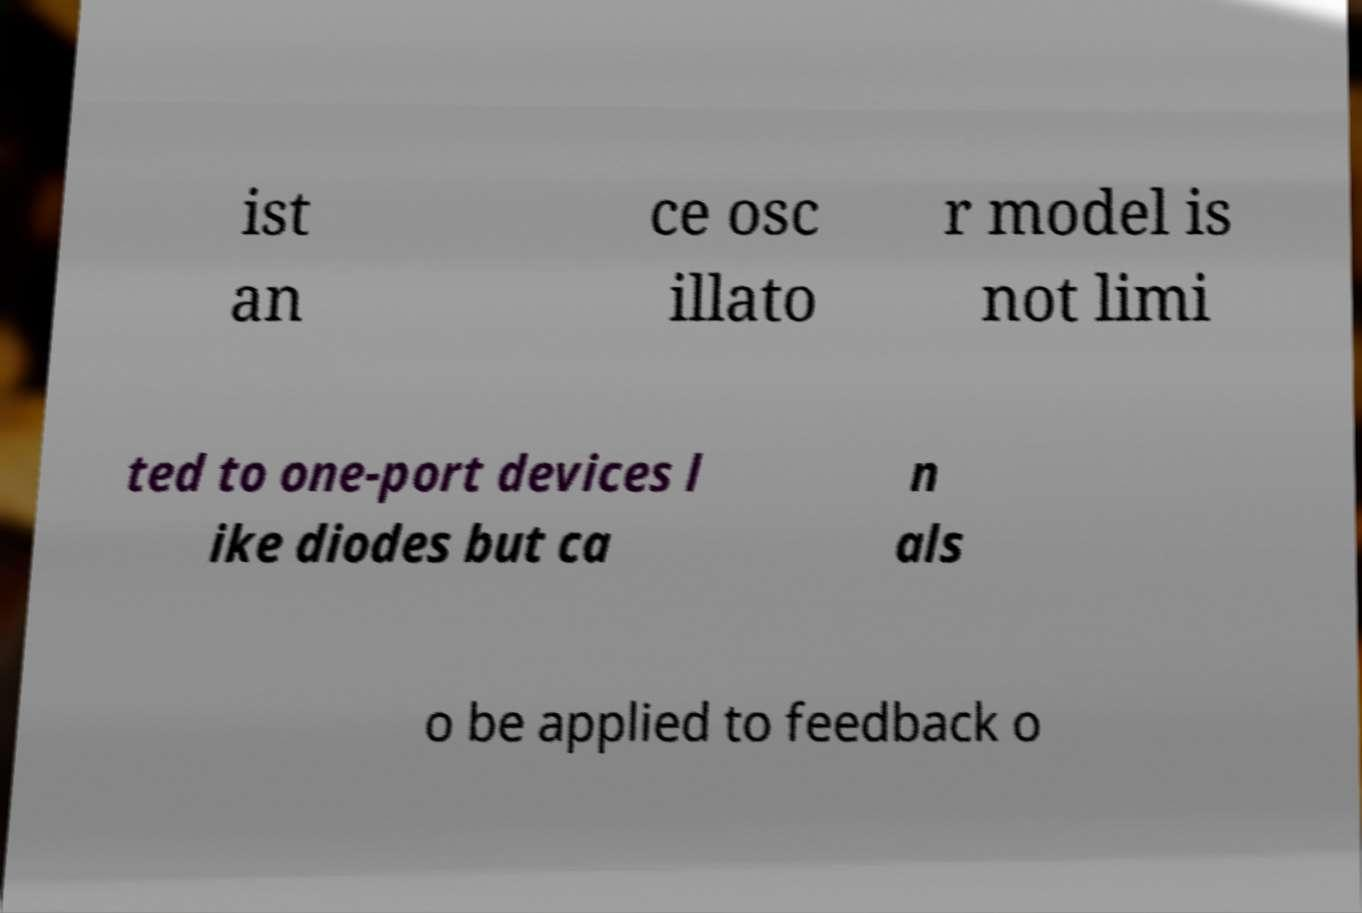There's text embedded in this image that I need extracted. Can you transcribe it verbatim? ist an ce osc illato r model is not limi ted to one-port devices l ike diodes but ca n als o be applied to feedback o 